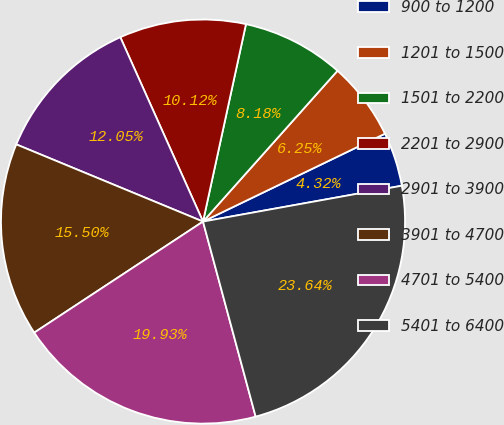Convert chart to OTSL. <chart><loc_0><loc_0><loc_500><loc_500><pie_chart><fcel>900 to 1200<fcel>1201 to 1500<fcel>1501 to 2200<fcel>2201 to 2900<fcel>2901 to 3900<fcel>3901 to 4700<fcel>4701 to 5400<fcel>5401 to 6400<nl><fcel>4.32%<fcel>6.25%<fcel>8.18%<fcel>10.12%<fcel>12.05%<fcel>15.5%<fcel>19.93%<fcel>23.64%<nl></chart> 